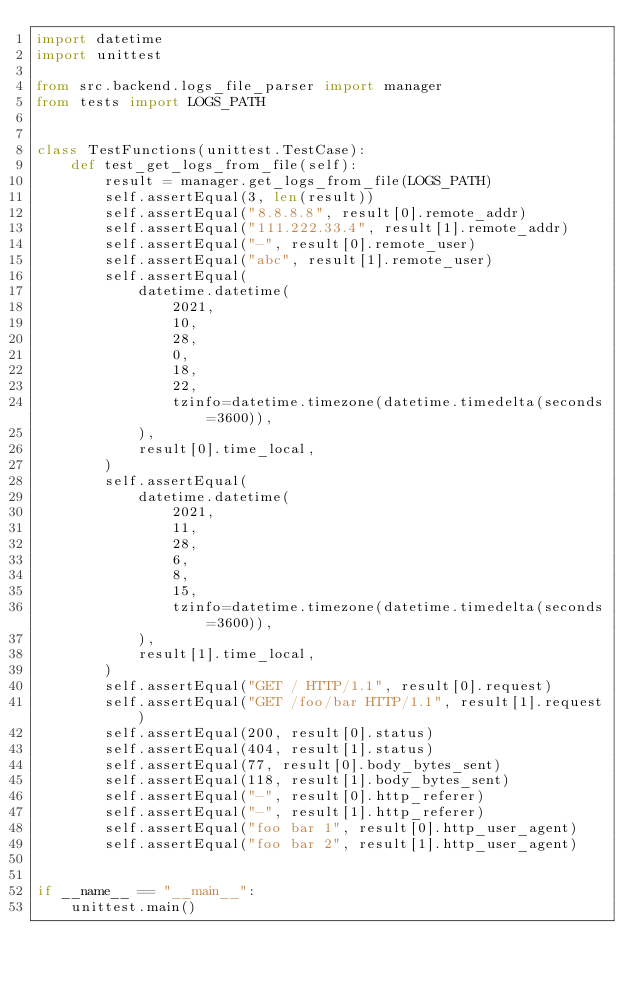Convert code to text. <code><loc_0><loc_0><loc_500><loc_500><_Python_>import datetime
import unittest

from src.backend.logs_file_parser import manager
from tests import LOGS_PATH


class TestFunctions(unittest.TestCase):
    def test_get_logs_from_file(self):
        result = manager.get_logs_from_file(LOGS_PATH)
        self.assertEqual(3, len(result))
        self.assertEqual("8.8.8.8", result[0].remote_addr)
        self.assertEqual("111.222.33.4", result[1].remote_addr)
        self.assertEqual("-", result[0].remote_user)
        self.assertEqual("abc", result[1].remote_user)
        self.assertEqual(
            datetime.datetime(
                2021,
                10,
                28,
                0,
                18,
                22,
                tzinfo=datetime.timezone(datetime.timedelta(seconds=3600)),
            ),
            result[0].time_local,
        )
        self.assertEqual(
            datetime.datetime(
                2021,
                11,
                28,
                6,
                8,
                15,
                tzinfo=datetime.timezone(datetime.timedelta(seconds=3600)),
            ),
            result[1].time_local,
        )
        self.assertEqual("GET / HTTP/1.1", result[0].request)
        self.assertEqual("GET /foo/bar HTTP/1.1", result[1].request)
        self.assertEqual(200, result[0].status)
        self.assertEqual(404, result[1].status)
        self.assertEqual(77, result[0].body_bytes_sent)
        self.assertEqual(118, result[1].body_bytes_sent)
        self.assertEqual("-", result[0].http_referer)
        self.assertEqual("-", result[1].http_referer)
        self.assertEqual("foo bar 1", result[0].http_user_agent)
        self.assertEqual("foo bar 2", result[1].http_user_agent)


if __name__ == "__main__":
    unittest.main()
</code> 